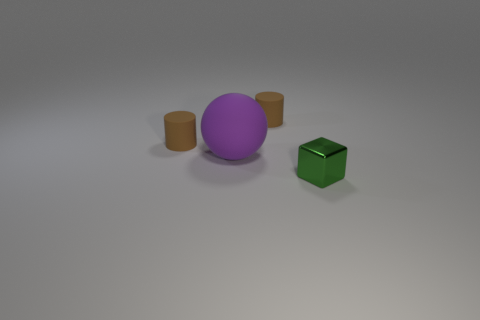Is there anything else that has the same size as the purple thing?
Provide a short and direct response. No. Is there any other thing that has the same material as the block?
Provide a succinct answer. No. Is there a small brown thing that is left of the small matte object that is to the right of the large purple matte thing?
Give a very brief answer. Yes. What color is the matte cylinder to the left of the rubber object that is in front of the brown object left of the purple object?
Make the answer very short. Brown. What material is the small thing that is on the right side of the brown matte cylinder that is on the right side of the big purple object?
Your answer should be compact. Metal. How many small matte things are right of the big purple matte object and left of the sphere?
Your answer should be compact. 0. How many other things are the same size as the ball?
Provide a succinct answer. 0. Does the small rubber thing that is to the right of the large purple rubber sphere have the same shape as the thing in front of the big purple rubber sphere?
Give a very brief answer. No. Are there any brown matte things left of the shiny cube?
Offer a very short reply. Yes. Are there any other things that have the same shape as the large purple matte object?
Offer a terse response. No. 